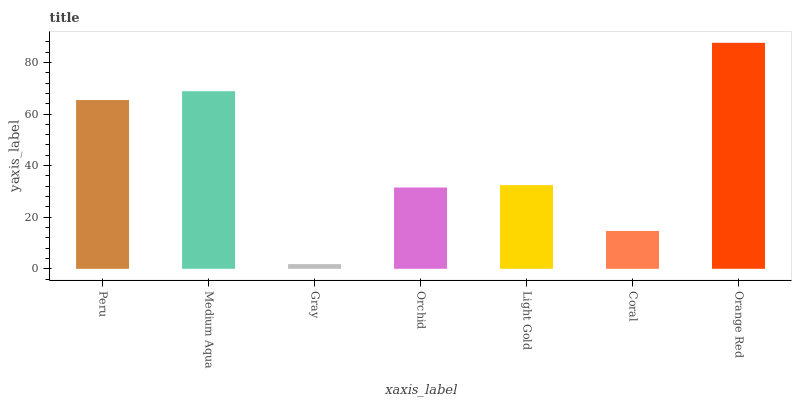Is Orange Red the maximum?
Answer yes or no. Yes. Is Medium Aqua the minimum?
Answer yes or no. No. Is Medium Aqua the maximum?
Answer yes or no. No. Is Medium Aqua greater than Peru?
Answer yes or no. Yes. Is Peru less than Medium Aqua?
Answer yes or no. Yes. Is Peru greater than Medium Aqua?
Answer yes or no. No. Is Medium Aqua less than Peru?
Answer yes or no. No. Is Light Gold the high median?
Answer yes or no. Yes. Is Light Gold the low median?
Answer yes or no. Yes. Is Coral the high median?
Answer yes or no. No. Is Coral the low median?
Answer yes or no. No. 